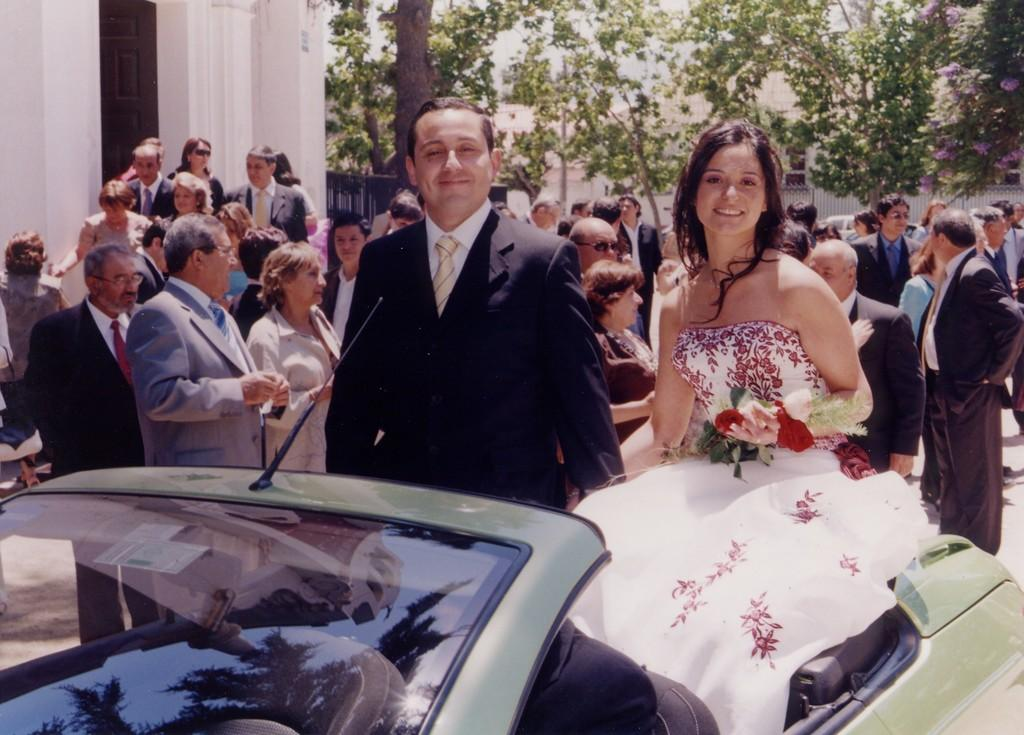What is the main subject of the image? The main subject of the image is a group of people. Can you describe the position of two people in the image? Two people are sitting on a car. What type of natural elements can be seen in the background of the image? There are trees at the back side of the image. What type of ball is being used by the group of people in the image? There is no ball present in the image. What kind of quilt is being used to cover the car in the image? There is no quilt present in the image; two people are sitting on the car. 